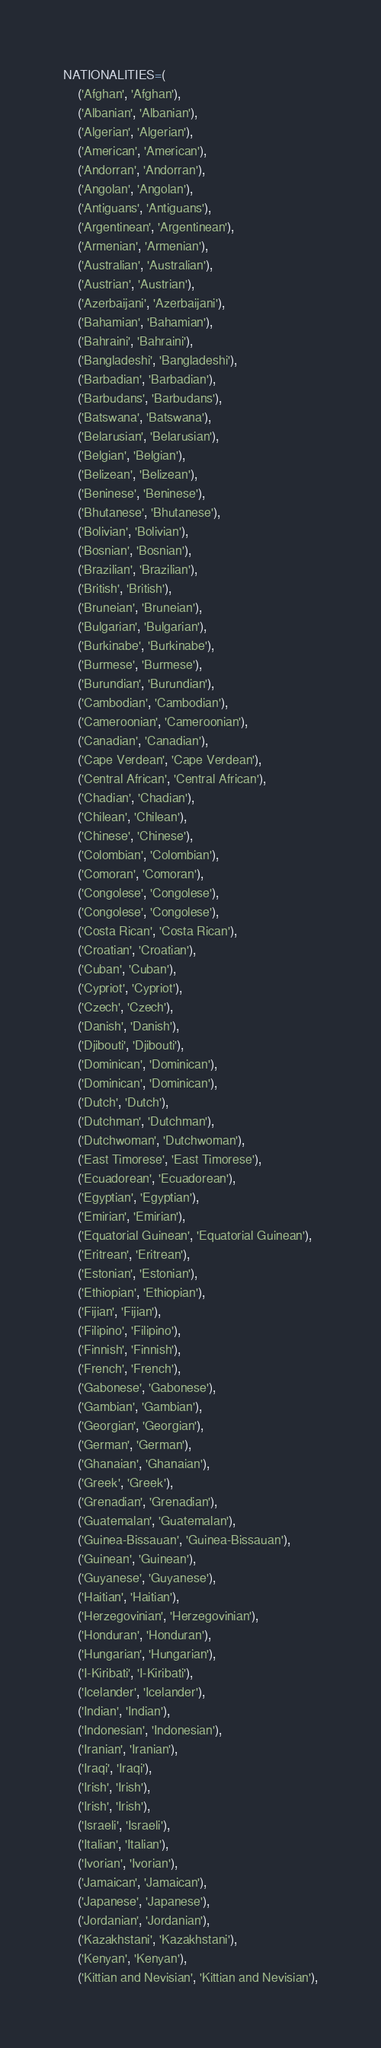Convert code to text. <code><loc_0><loc_0><loc_500><loc_500><_Python_>NATIONALITIES=(
    ('Afghan', 'Afghan'),
    ('Albanian', 'Albanian'),
    ('Algerian', 'Algerian'),
    ('American', 'American'),
    ('Andorran', 'Andorran'),
    ('Angolan', 'Angolan'),
    ('Antiguans', 'Antiguans'),
    ('Argentinean', 'Argentinean'),
    ('Armenian', 'Armenian'),
    ('Australian', 'Australian'),
    ('Austrian', 'Austrian'),
    ('Azerbaijani', 'Azerbaijani'),
    ('Bahamian', 'Bahamian'),
    ('Bahraini', 'Bahraini'),
    ('Bangladeshi', 'Bangladeshi'),
    ('Barbadian', 'Barbadian'),
    ('Barbudans', 'Barbudans'),
    ('Batswana', 'Batswana'),
    ('Belarusian', 'Belarusian'),
    ('Belgian', 'Belgian'),
    ('Belizean', 'Belizean'),
    ('Beninese', 'Beninese'),
    ('Bhutanese', 'Bhutanese'),
    ('Bolivian', 'Bolivian'),
    ('Bosnian', 'Bosnian'),
    ('Brazilian', 'Brazilian'),
    ('British', 'British'),
    ('Bruneian', 'Bruneian'),
    ('Bulgarian', 'Bulgarian'),
    ('Burkinabe', 'Burkinabe'),
    ('Burmese', 'Burmese'),
    ('Burundian', 'Burundian'),
    ('Cambodian', 'Cambodian'),
    ('Cameroonian', 'Cameroonian'),
    ('Canadian', 'Canadian'),
    ('Cape Verdean', 'Cape Verdean'),
    ('Central African', 'Central African'),
    ('Chadian', 'Chadian'),
    ('Chilean', 'Chilean'),
    ('Chinese', 'Chinese'),
    ('Colombian', 'Colombian'),
    ('Comoran', 'Comoran'),
    ('Congolese', 'Congolese'),
    ('Congolese', 'Congolese'),
    ('Costa Rican', 'Costa Rican'),
    ('Croatian', 'Croatian'),
    ('Cuban', 'Cuban'),
    ('Cypriot', 'Cypriot'),
    ('Czech', 'Czech'),
    ('Danish', 'Danish'),
    ('Djibouti', 'Djibouti'),
    ('Dominican', 'Dominican'),
    ('Dominican', 'Dominican'),
    ('Dutch', 'Dutch'),
    ('Dutchman', 'Dutchman'),
    ('Dutchwoman', 'Dutchwoman'),
    ('East Timorese', 'East Timorese'),
    ('Ecuadorean', 'Ecuadorean'),
    ('Egyptian', 'Egyptian'),
    ('Emirian', 'Emirian'),
    ('Equatorial Guinean', 'Equatorial Guinean'),
    ('Eritrean', 'Eritrean'),
    ('Estonian', 'Estonian'),
    ('Ethiopian', 'Ethiopian'),
    ('Fijian', 'Fijian'),
    ('Filipino', 'Filipino'),
    ('Finnish', 'Finnish'),
    ('French', 'French'),
    ('Gabonese', 'Gabonese'),
    ('Gambian', 'Gambian'),
    ('Georgian', 'Georgian'),
    ('German', 'German'),
    ('Ghanaian', 'Ghanaian'),
    ('Greek', 'Greek'),
    ('Grenadian', 'Grenadian'),
    ('Guatemalan', 'Guatemalan'),
    ('Guinea-Bissauan', 'Guinea-Bissauan'),
    ('Guinean', 'Guinean'),
    ('Guyanese', 'Guyanese'),
    ('Haitian', 'Haitian'),
    ('Herzegovinian', 'Herzegovinian'),
    ('Honduran', 'Honduran'),
    ('Hungarian', 'Hungarian'),
    ('I-Kiribati', 'I-Kiribati'),
    ('Icelander', 'Icelander'),
    ('Indian', 'Indian'),
    ('Indonesian', 'Indonesian'),
    ('Iranian', 'Iranian'),
    ('Iraqi', 'Iraqi'),
    ('Irish', 'Irish'),
    ('Irish', 'Irish'),
    ('Israeli', 'Israeli'),
    ('Italian', 'Italian'),
    ('Ivorian', 'Ivorian'),
    ('Jamaican', 'Jamaican'),
    ('Japanese', 'Japanese'),
    ('Jordanian', 'Jordanian'),
    ('Kazakhstani', 'Kazakhstani'),
    ('Kenyan', 'Kenyan'),
    ('Kittian and Nevisian', 'Kittian and Nevisian'),</code> 